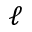Convert formula to latex. <formula><loc_0><loc_0><loc_500><loc_500>\ell</formula> 